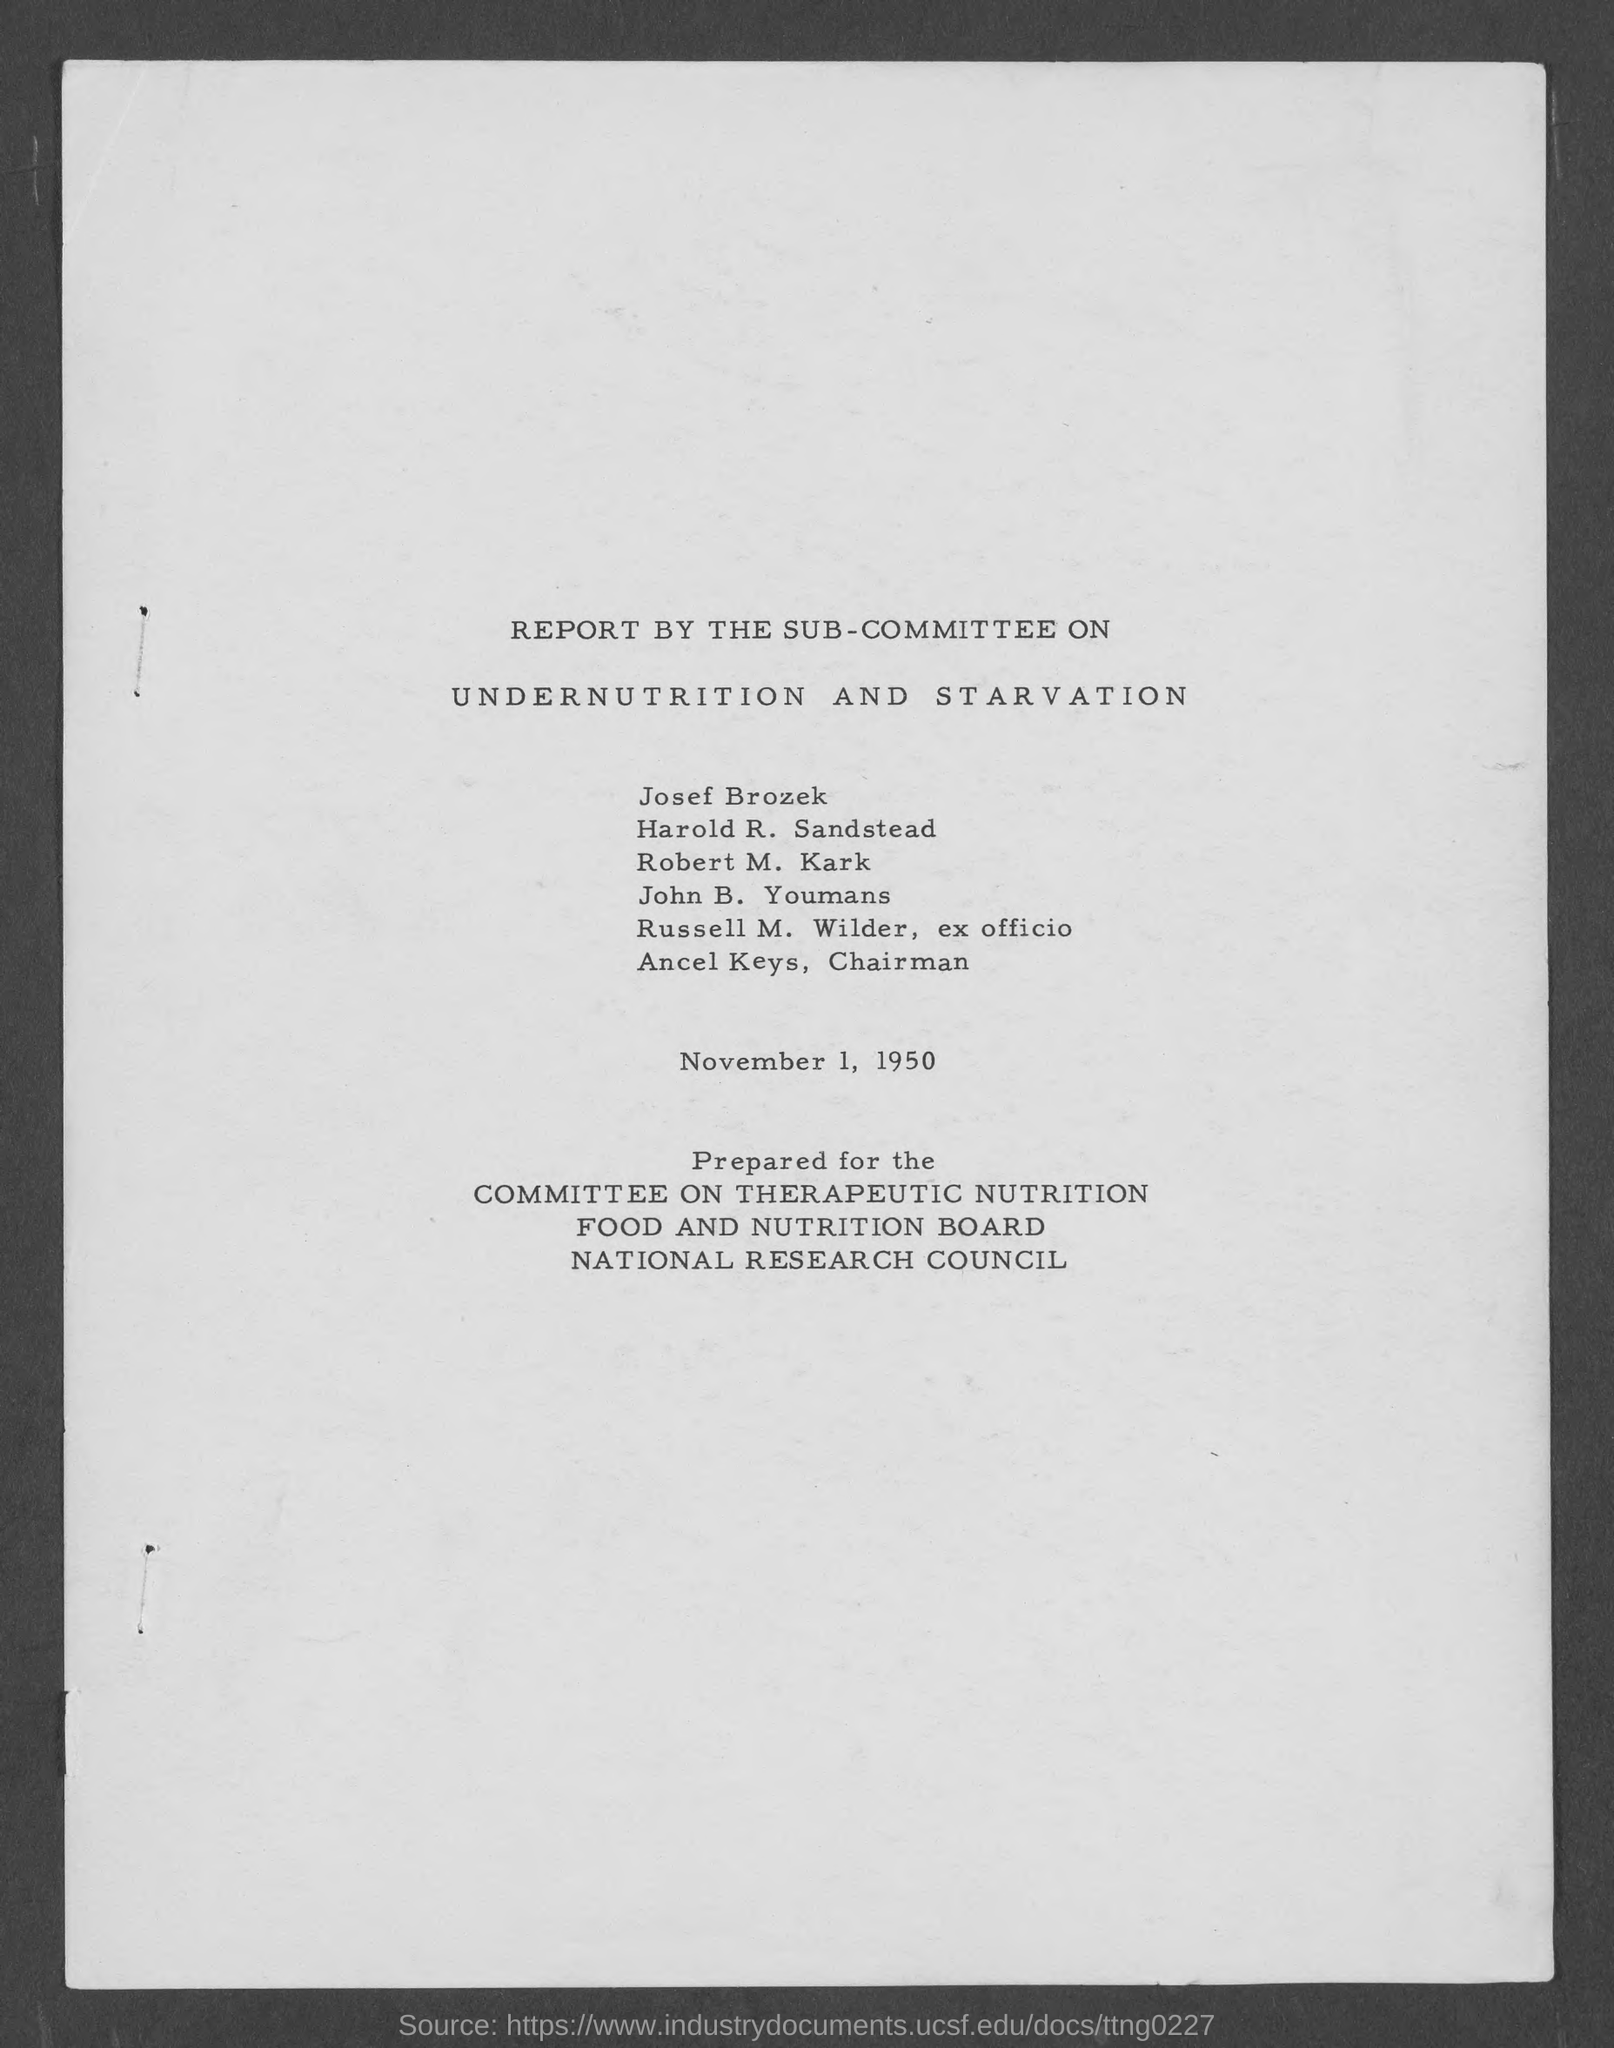What is the date mentioned in document?
Make the answer very short. November 1, 1950. What is the position of russell m. wilder ?
Keep it short and to the point. Ex officio. What is the position of ancel keys ?
Your answer should be very brief. Chairman. 